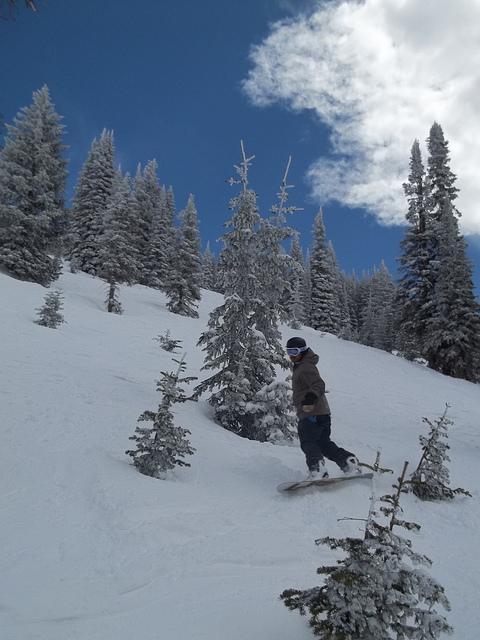How many buses are parked side by side?
Give a very brief answer. 0. 